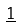<formula> <loc_0><loc_0><loc_500><loc_500>\underline { 1 }</formula> 